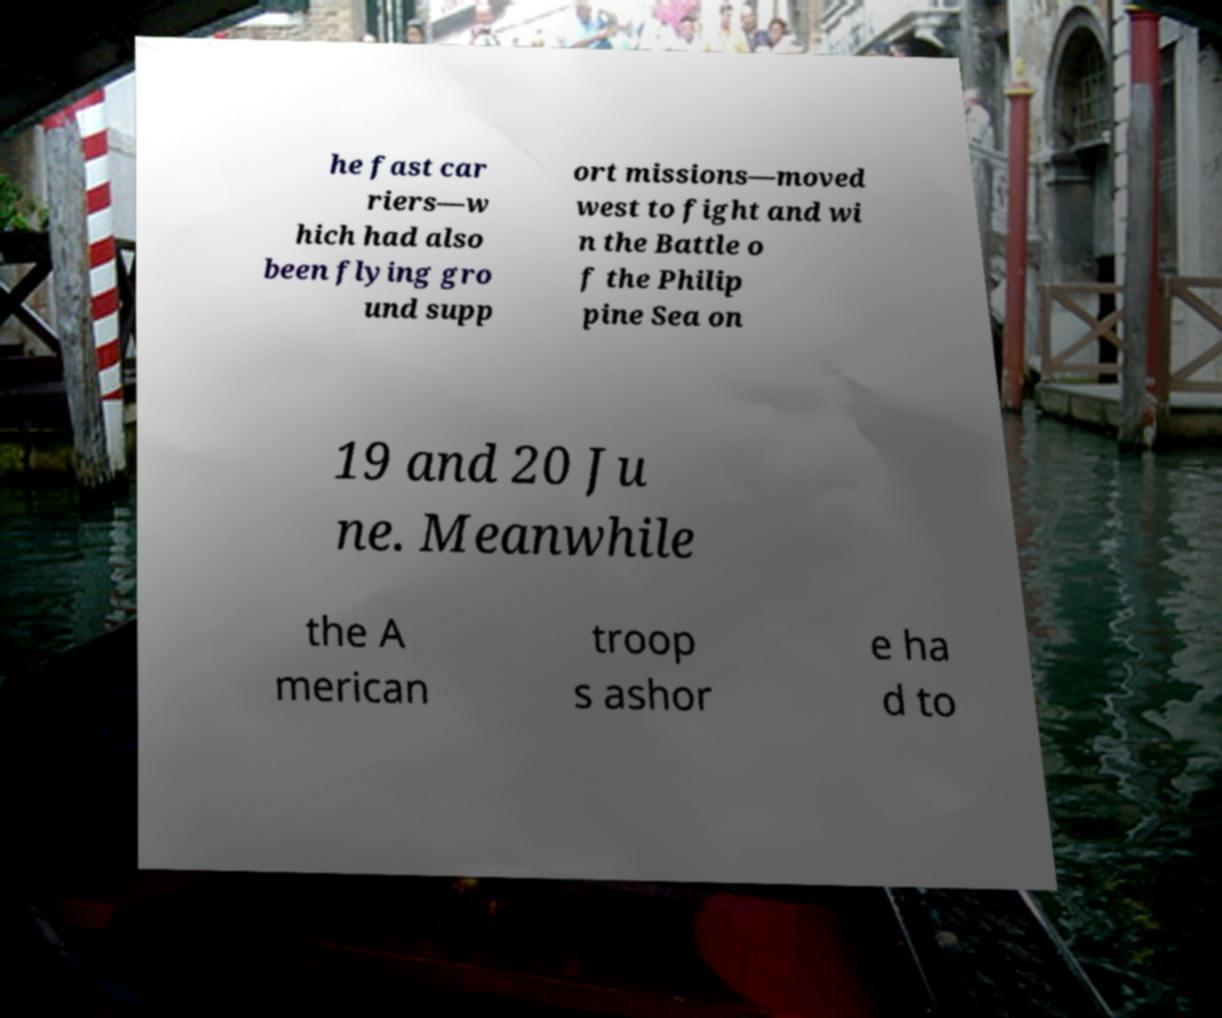Please identify and transcribe the text found in this image. he fast car riers—w hich had also been flying gro und supp ort missions—moved west to fight and wi n the Battle o f the Philip pine Sea on 19 and 20 Ju ne. Meanwhile the A merican troop s ashor e ha d to 